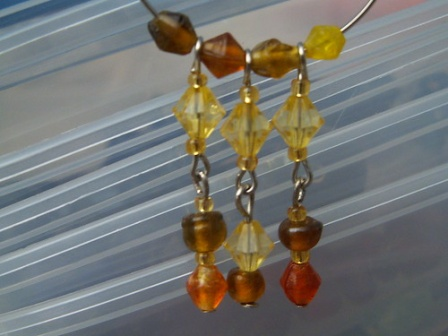Can you write a poem inspired by these earrings? Dangling in twilight's embrace,
Beads of earth, sun, and fire trace,
A story spun in a silvery lace,
Of elegance, beauty, and grace.

From a sunset's final flicker,
To moments pure and quicker,
They whisper tales much thicker,
Than any eye could see or ticker.

Bound by chains so fine and bright,
They gleam in the gentle light,
Orbs that capture day and night,
Silent keepers of joy and might.

In their dance, colors blend,
Telling tales that never end,
Of earth's heart and sky's rend,
As they in evening's twilight tend. 